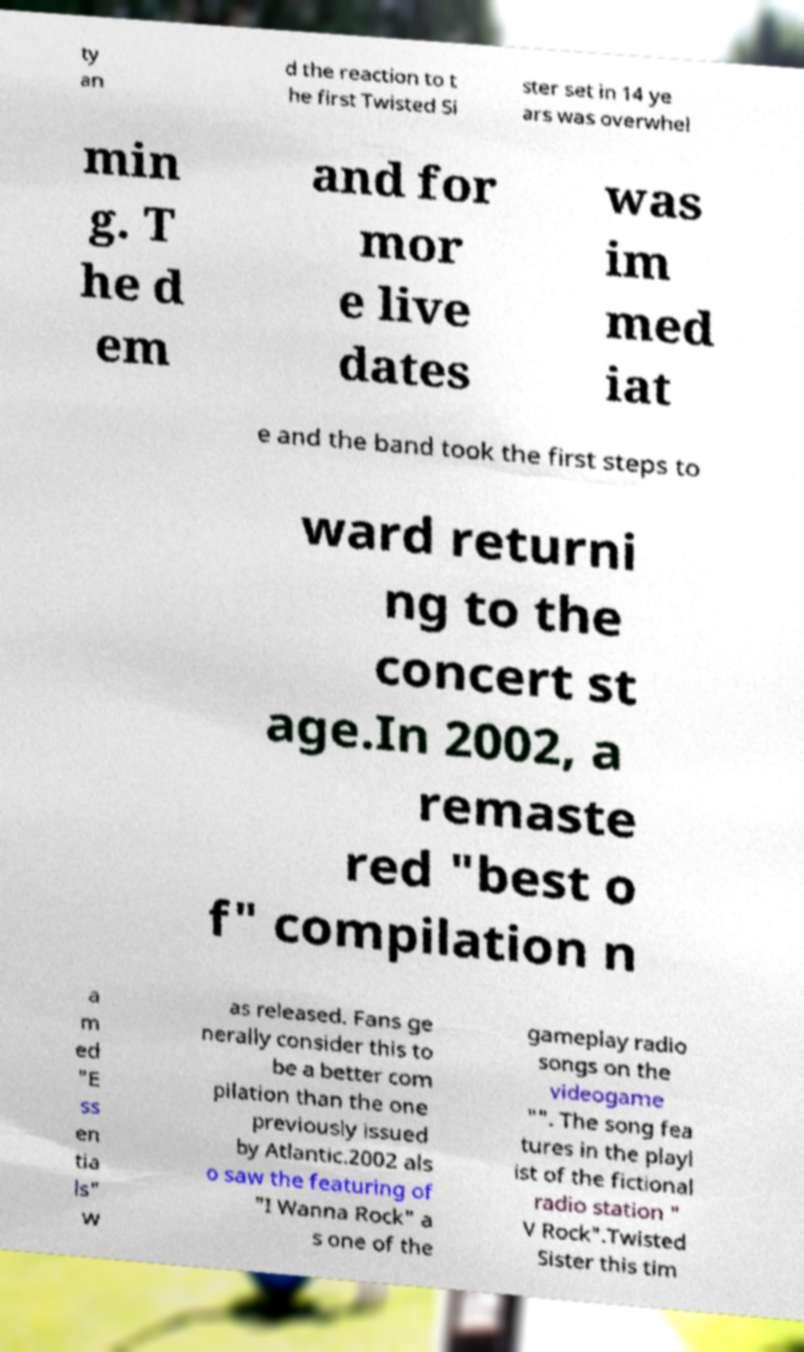Please read and relay the text visible in this image. What does it say? ty an d the reaction to t he first Twisted Si ster set in 14 ye ars was overwhel min g. T he d em and for mor e live dates was im med iat e and the band took the first steps to ward returni ng to the concert st age.In 2002, a remaste red "best o f" compilation n a m ed "E ss en tia ls" w as released. Fans ge nerally consider this to be a better com pilation than the one previously issued by Atlantic.2002 als o saw the featuring of "I Wanna Rock" a s one of the gameplay radio songs on the videogame "". The song fea tures in the playl ist of the fictional radio station " V Rock".Twisted Sister this tim 